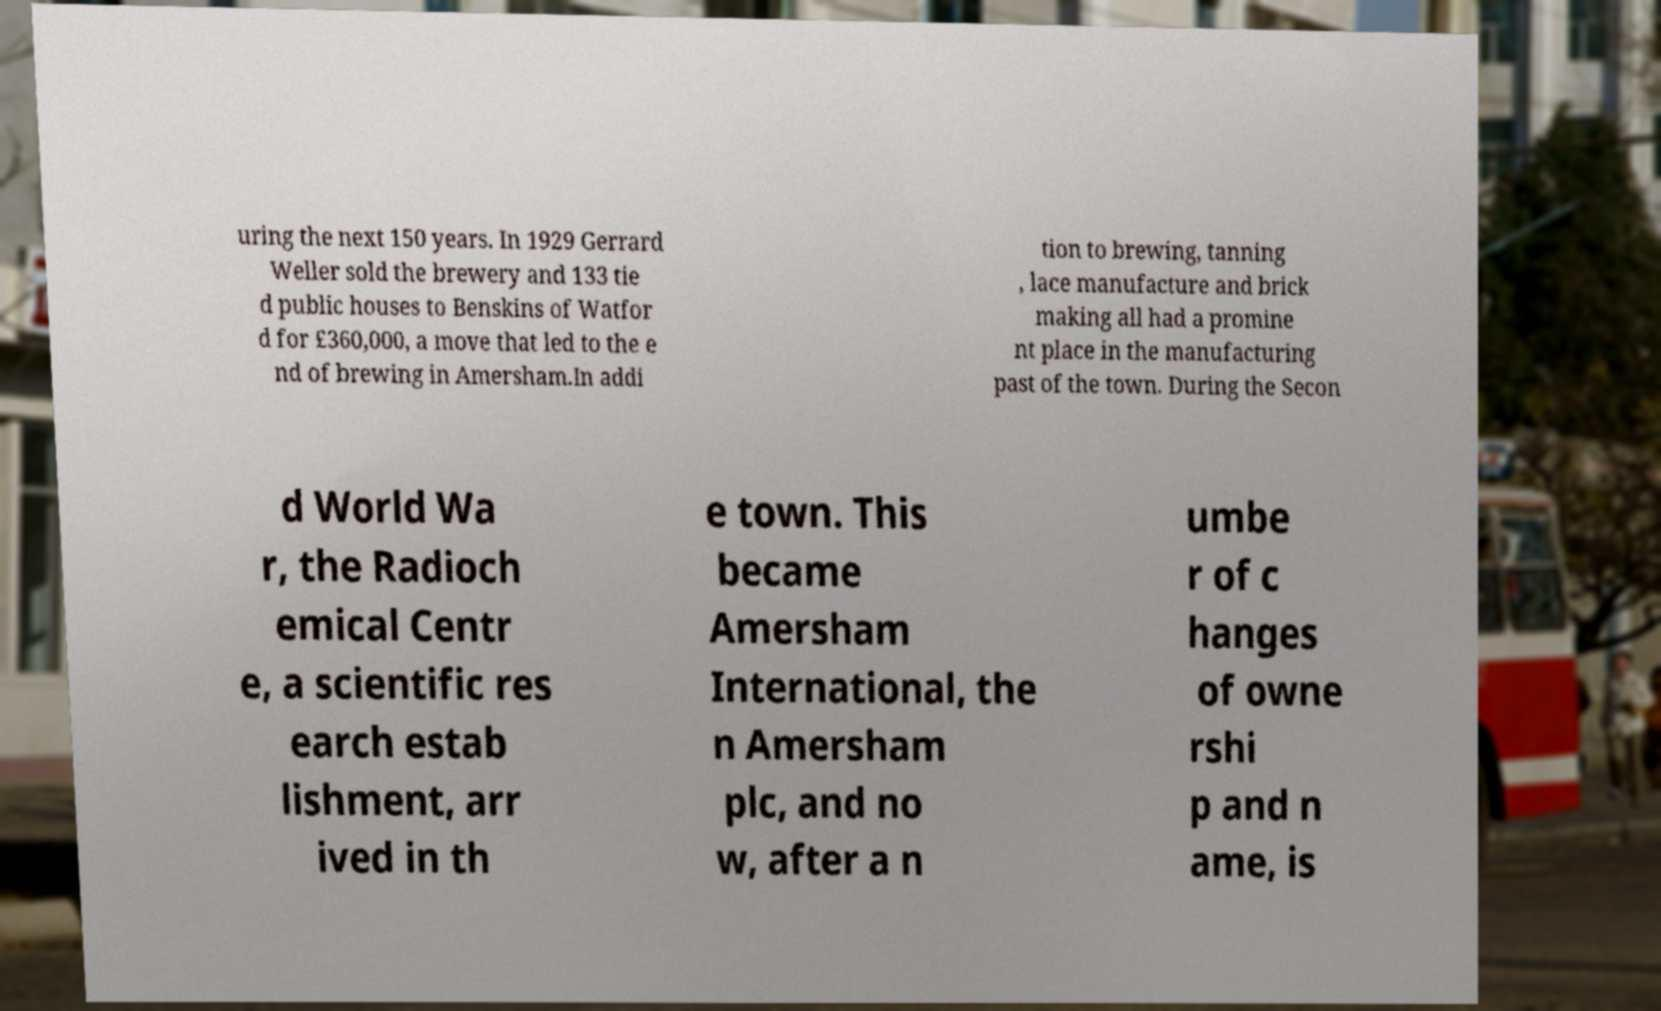Can you accurately transcribe the text from the provided image for me? uring the next 150 years. In 1929 Gerrard Weller sold the brewery and 133 tie d public houses to Benskins of Watfor d for £360,000, a move that led to the e nd of brewing in Amersham.In addi tion to brewing, tanning , lace manufacture and brick making all had a promine nt place in the manufacturing past of the town. During the Secon d World Wa r, the Radioch emical Centr e, a scientific res earch estab lishment, arr ived in th e town. This became Amersham International, the n Amersham plc, and no w, after a n umbe r of c hanges of owne rshi p and n ame, is 